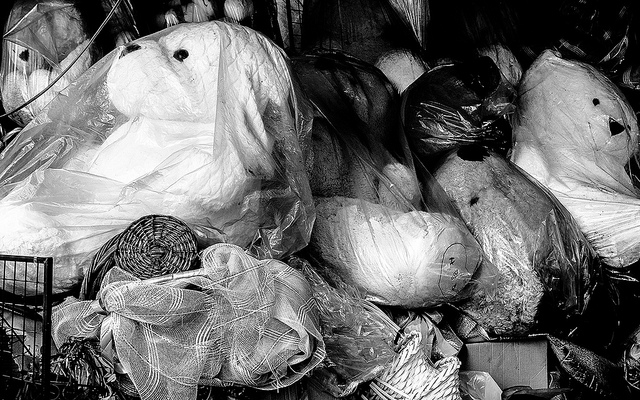What kind of items are visible in this image? The image shows an assortment of items, most likely in a storage area or second-hand shop. We can see objects wrapped in plastic, which may include decorations, household items, and potentially some plush toys, although it's not clear if they are teddy bears. The collection seems eclectic and could be indicative of items awaiting resale or donation. 